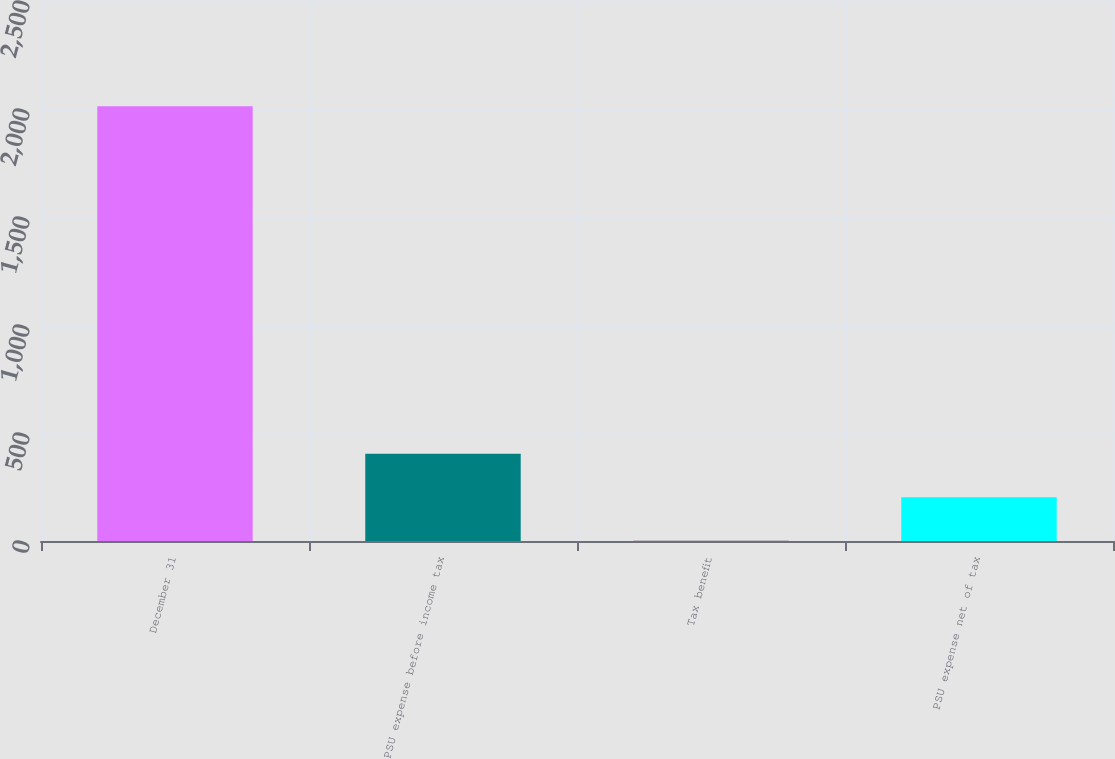<chart> <loc_0><loc_0><loc_500><loc_500><bar_chart><fcel>December 31<fcel>PSU expense before income tax<fcel>Tax benefit<fcel>PSU expense net of tax<nl><fcel>2013<fcel>403.4<fcel>1<fcel>202.2<nl></chart> 